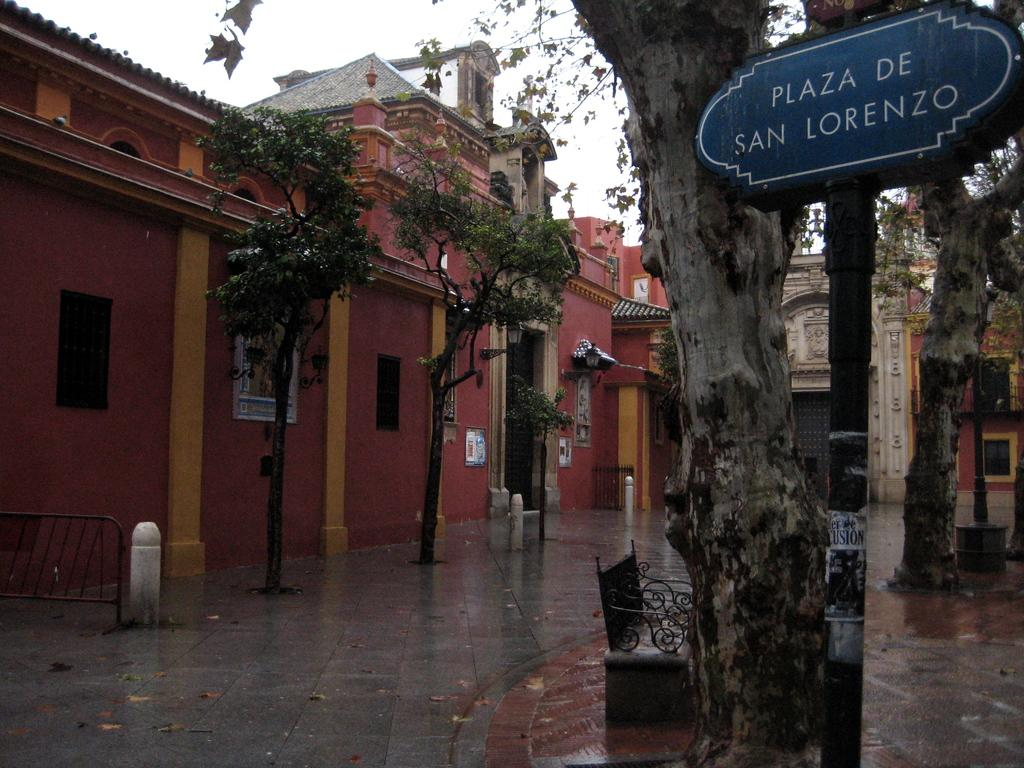<image>
Offer a succinct explanation of the picture presented. A sign identifies this location as Plaza De San Lorenzo. 